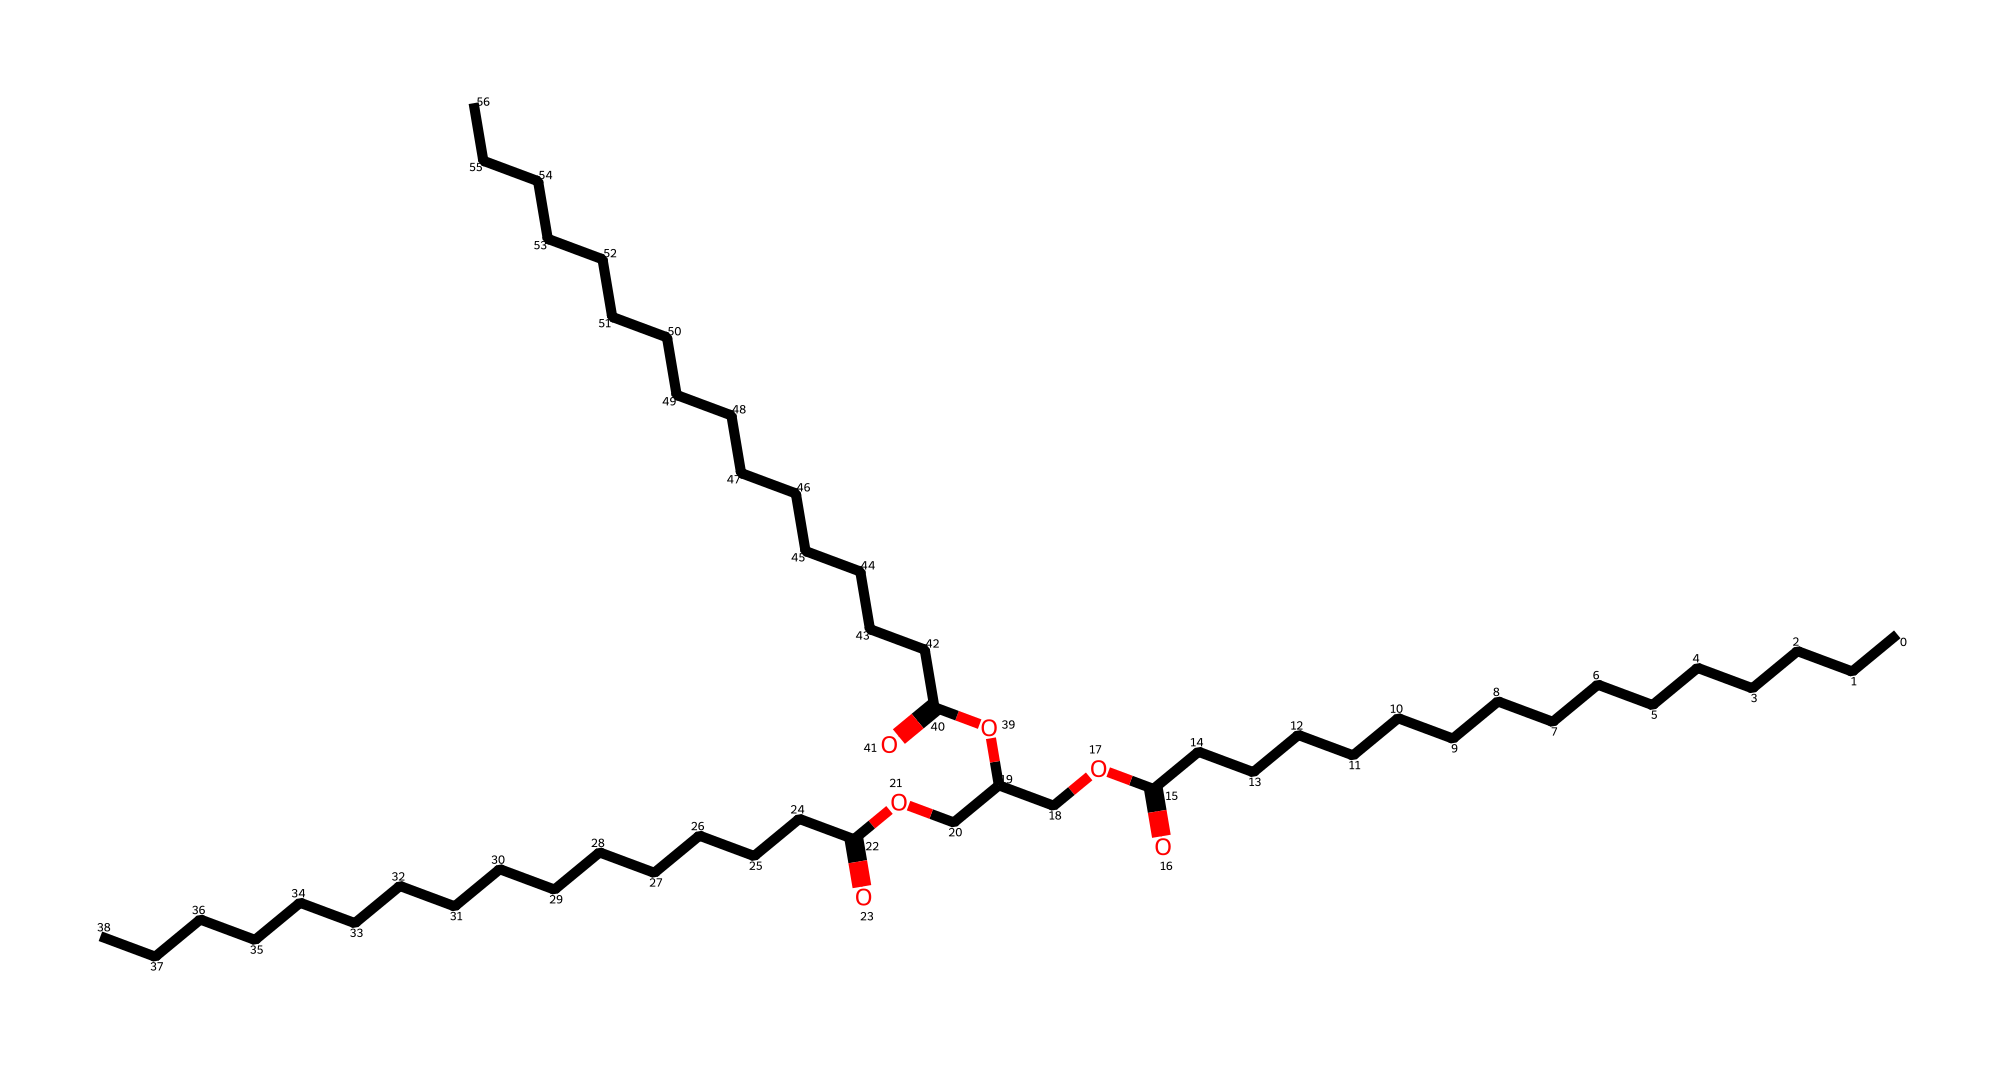What is the main functional group present in this chemical structure? The chemical structure contains a carboxylic acid functional group at one end due to the presence of the -COOH moiety. This is identified by the carbon double-bonded to oxygen and single-bonded to a hydroxyl group.
Answer: carboxylic acid How many carbon atoms are in the entire structure? By analyzing the structure, we count the carbons in the long carbon chains and in the functional groups. There are 24 carbon atoms total, evident from the continuous carbon chain along with the carbon in each ester and the carboxylic acid group.
Answer: 24 What type of lipid is represented by this chemical? The presence of multiple long carbon chains and ester functional groups indicates this is a triglyceride, specifically a form of fat. This categorization comes from its structure of glycerol esterified with three fatty acids.
Answer: triglyceride How many ester linkages are found in this chemical? The chemical structure has three ester groups, which can be identified where the carboxylic acid groups have reacted with hydroxyl groups. Each ester linkage connects a fatty acid to the glycerol backbone.
Answer: 3 What is the chain length of the longest fatty acid present in this structure? The longest fatty acid chain can be seen from the carbon count on one of the chains; this particular fatty acid has 16 carbon atoms, as inferred from counting the carbon atoms in that segment of the structure.
Answer: 16 